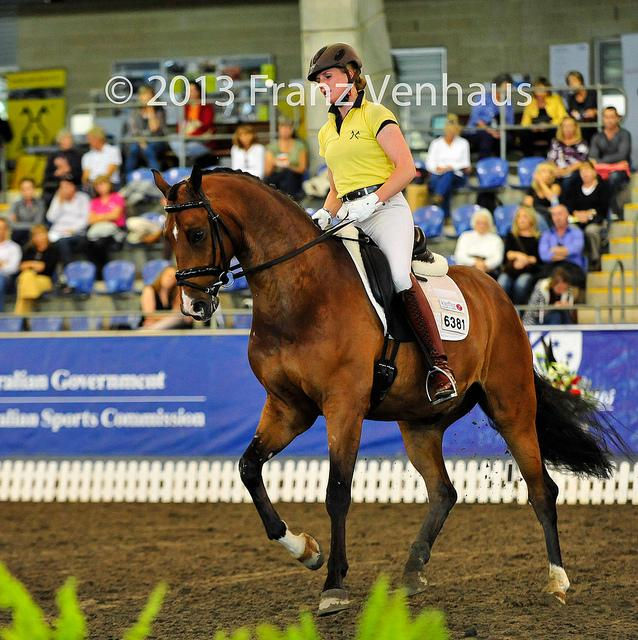What is the woman in yellow doing on the horse?

Choices:
A) feeding
B) competing
C) learning
D) cleaning competing 